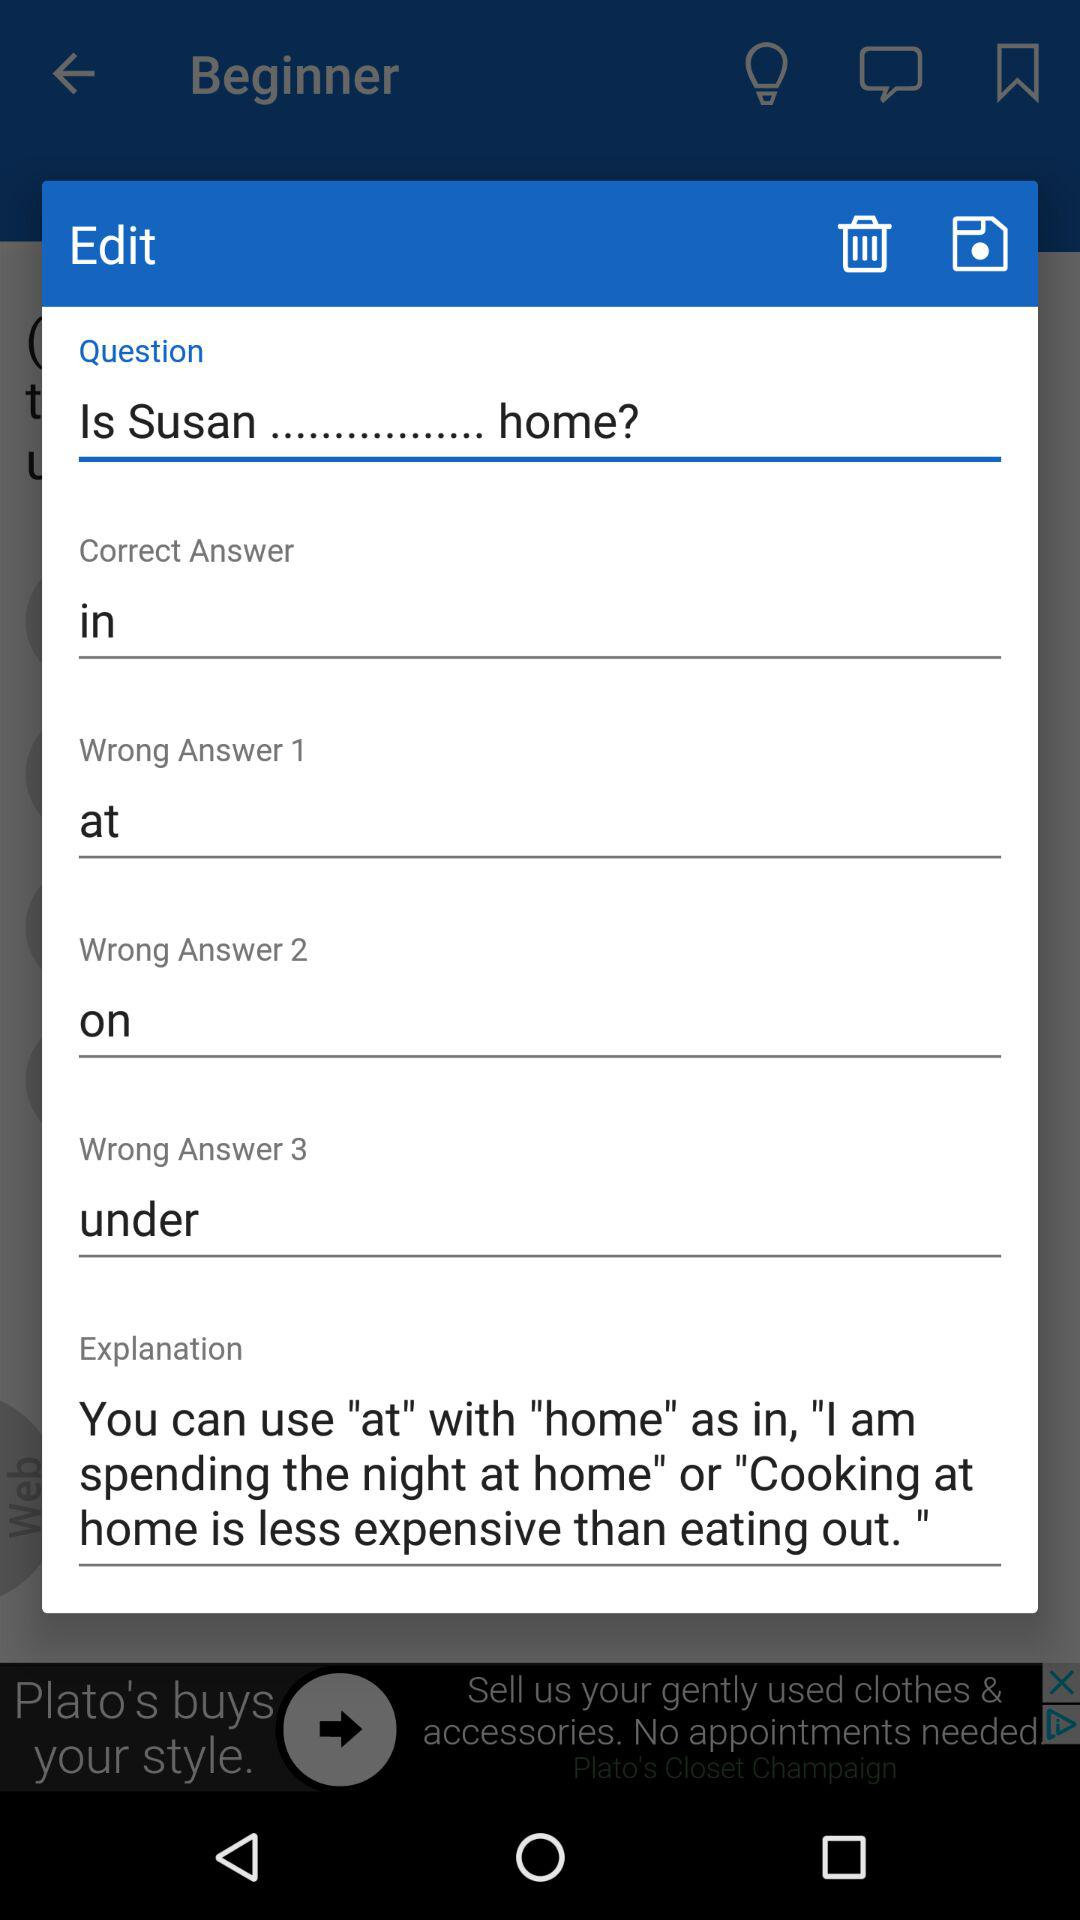What's the question? The question is "Is Susan............ home?". 